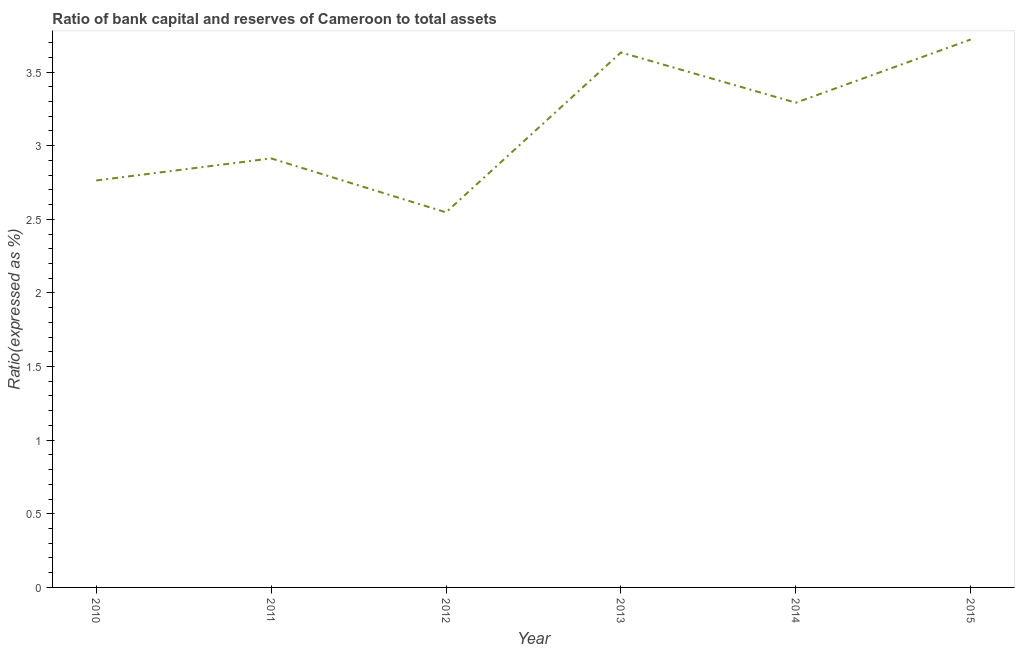What is the bank capital to assets ratio in 2011?
Keep it short and to the point. 2.91. Across all years, what is the maximum bank capital to assets ratio?
Make the answer very short. 3.72. Across all years, what is the minimum bank capital to assets ratio?
Keep it short and to the point. 2.55. In which year was the bank capital to assets ratio maximum?
Your answer should be compact. 2015. What is the sum of the bank capital to assets ratio?
Your response must be concise. 18.87. What is the difference between the bank capital to assets ratio in 2010 and 2014?
Make the answer very short. -0.53. What is the average bank capital to assets ratio per year?
Your response must be concise. 3.14. What is the median bank capital to assets ratio?
Your answer should be compact. 3.1. What is the ratio of the bank capital to assets ratio in 2011 to that in 2013?
Your response must be concise. 0.8. What is the difference between the highest and the second highest bank capital to assets ratio?
Your response must be concise. 0.09. Is the sum of the bank capital to assets ratio in 2011 and 2014 greater than the maximum bank capital to assets ratio across all years?
Your response must be concise. Yes. What is the difference between the highest and the lowest bank capital to assets ratio?
Your response must be concise. 1.17. In how many years, is the bank capital to assets ratio greater than the average bank capital to assets ratio taken over all years?
Keep it short and to the point. 3. How many years are there in the graph?
Your answer should be very brief. 6. Does the graph contain grids?
Make the answer very short. No. What is the title of the graph?
Give a very brief answer. Ratio of bank capital and reserves of Cameroon to total assets. What is the label or title of the X-axis?
Your response must be concise. Year. What is the label or title of the Y-axis?
Ensure brevity in your answer.  Ratio(expressed as %). What is the Ratio(expressed as %) of 2010?
Keep it short and to the point. 2.76. What is the Ratio(expressed as %) in 2011?
Provide a short and direct response. 2.91. What is the Ratio(expressed as %) in 2012?
Offer a terse response. 2.55. What is the Ratio(expressed as %) in 2013?
Your answer should be compact. 3.63. What is the Ratio(expressed as %) of 2014?
Keep it short and to the point. 3.29. What is the Ratio(expressed as %) in 2015?
Offer a very short reply. 3.72. What is the difference between the Ratio(expressed as %) in 2010 and 2011?
Provide a succinct answer. -0.15. What is the difference between the Ratio(expressed as %) in 2010 and 2012?
Make the answer very short. 0.22. What is the difference between the Ratio(expressed as %) in 2010 and 2013?
Offer a very short reply. -0.87. What is the difference between the Ratio(expressed as %) in 2010 and 2014?
Ensure brevity in your answer.  -0.53. What is the difference between the Ratio(expressed as %) in 2010 and 2015?
Keep it short and to the point. -0.96. What is the difference between the Ratio(expressed as %) in 2011 and 2012?
Your answer should be compact. 0.37. What is the difference between the Ratio(expressed as %) in 2011 and 2013?
Your answer should be very brief. -0.72. What is the difference between the Ratio(expressed as %) in 2011 and 2014?
Make the answer very short. -0.38. What is the difference between the Ratio(expressed as %) in 2011 and 2015?
Provide a succinct answer. -0.81. What is the difference between the Ratio(expressed as %) in 2012 and 2013?
Your answer should be very brief. -1.09. What is the difference between the Ratio(expressed as %) in 2012 and 2014?
Offer a terse response. -0.74. What is the difference between the Ratio(expressed as %) in 2012 and 2015?
Give a very brief answer. -1.17. What is the difference between the Ratio(expressed as %) in 2013 and 2014?
Make the answer very short. 0.34. What is the difference between the Ratio(expressed as %) in 2013 and 2015?
Provide a succinct answer. -0.09. What is the difference between the Ratio(expressed as %) in 2014 and 2015?
Make the answer very short. -0.43. What is the ratio of the Ratio(expressed as %) in 2010 to that in 2011?
Your response must be concise. 0.95. What is the ratio of the Ratio(expressed as %) in 2010 to that in 2012?
Your answer should be very brief. 1.08. What is the ratio of the Ratio(expressed as %) in 2010 to that in 2013?
Provide a succinct answer. 0.76. What is the ratio of the Ratio(expressed as %) in 2010 to that in 2014?
Keep it short and to the point. 0.84. What is the ratio of the Ratio(expressed as %) in 2010 to that in 2015?
Give a very brief answer. 0.74. What is the ratio of the Ratio(expressed as %) in 2011 to that in 2012?
Provide a short and direct response. 1.14. What is the ratio of the Ratio(expressed as %) in 2011 to that in 2013?
Keep it short and to the point. 0.8. What is the ratio of the Ratio(expressed as %) in 2011 to that in 2014?
Give a very brief answer. 0.89. What is the ratio of the Ratio(expressed as %) in 2011 to that in 2015?
Your answer should be compact. 0.78. What is the ratio of the Ratio(expressed as %) in 2012 to that in 2013?
Your answer should be compact. 0.7. What is the ratio of the Ratio(expressed as %) in 2012 to that in 2014?
Provide a succinct answer. 0.77. What is the ratio of the Ratio(expressed as %) in 2012 to that in 2015?
Make the answer very short. 0.69. What is the ratio of the Ratio(expressed as %) in 2013 to that in 2014?
Provide a succinct answer. 1.1. What is the ratio of the Ratio(expressed as %) in 2014 to that in 2015?
Your response must be concise. 0.89. 